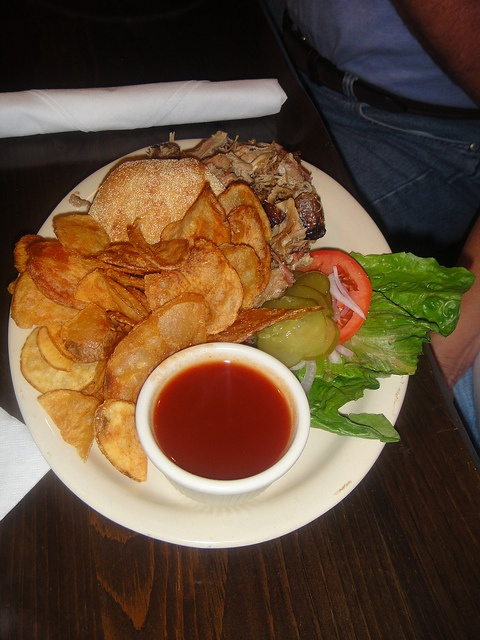Describe the objects in this image and their specific colors. I can see dining table in black, darkgray, maroon, and lightgray tones, people in black, maroon, and purple tones, bowl in black, maroon, ivory, and tan tones, sandwich in black, brown, tan, maroon, and gray tones, and broccoli in black, darkgreen, and olive tones in this image. 